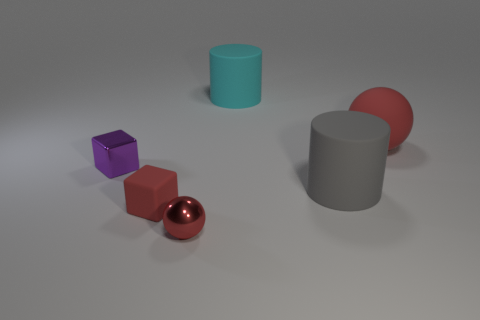Add 2 tiny purple metal things. How many objects exist? 8 Subtract all rubber cylinders. Subtract all small blue objects. How many objects are left? 4 Add 5 large things. How many large things are left? 8 Add 4 tiny cyan blocks. How many tiny cyan blocks exist? 4 Subtract 0 green blocks. How many objects are left? 6 